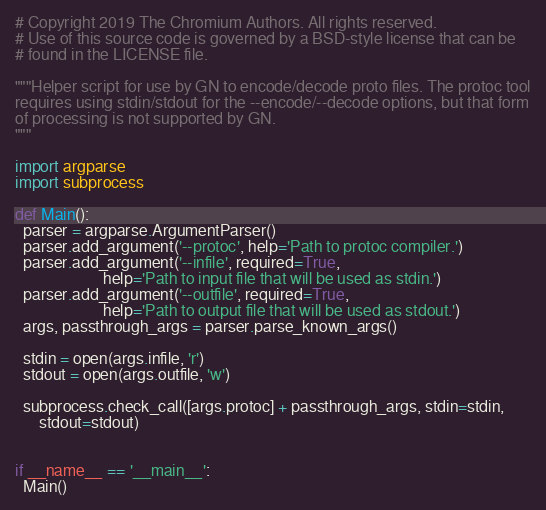<code> <loc_0><loc_0><loc_500><loc_500><_Python_># Copyright 2019 The Chromium Authors. All rights reserved.
# Use of this source code is governed by a BSD-style license that can be
# found in the LICENSE file.

"""Helper script for use by GN to encode/decode proto files. The protoc tool
requires using stdin/stdout for the --encode/--decode options, but that form
of processing is not supported by GN.
"""

import argparse
import subprocess

def Main():
  parser = argparse.ArgumentParser()
  parser.add_argument('--protoc', help='Path to protoc compiler.')
  parser.add_argument('--infile', required=True,
                      help='Path to input file that will be used as stdin.')
  parser.add_argument('--outfile', required=True,
                      help='Path to output file that will be used as stdout.')
  args, passthrough_args = parser.parse_known_args()

  stdin = open(args.infile, 'r')
  stdout = open(args.outfile, 'w')

  subprocess.check_call([args.protoc] + passthrough_args, stdin=stdin,
      stdout=stdout)


if __name__ == '__main__':
  Main()
</code> 